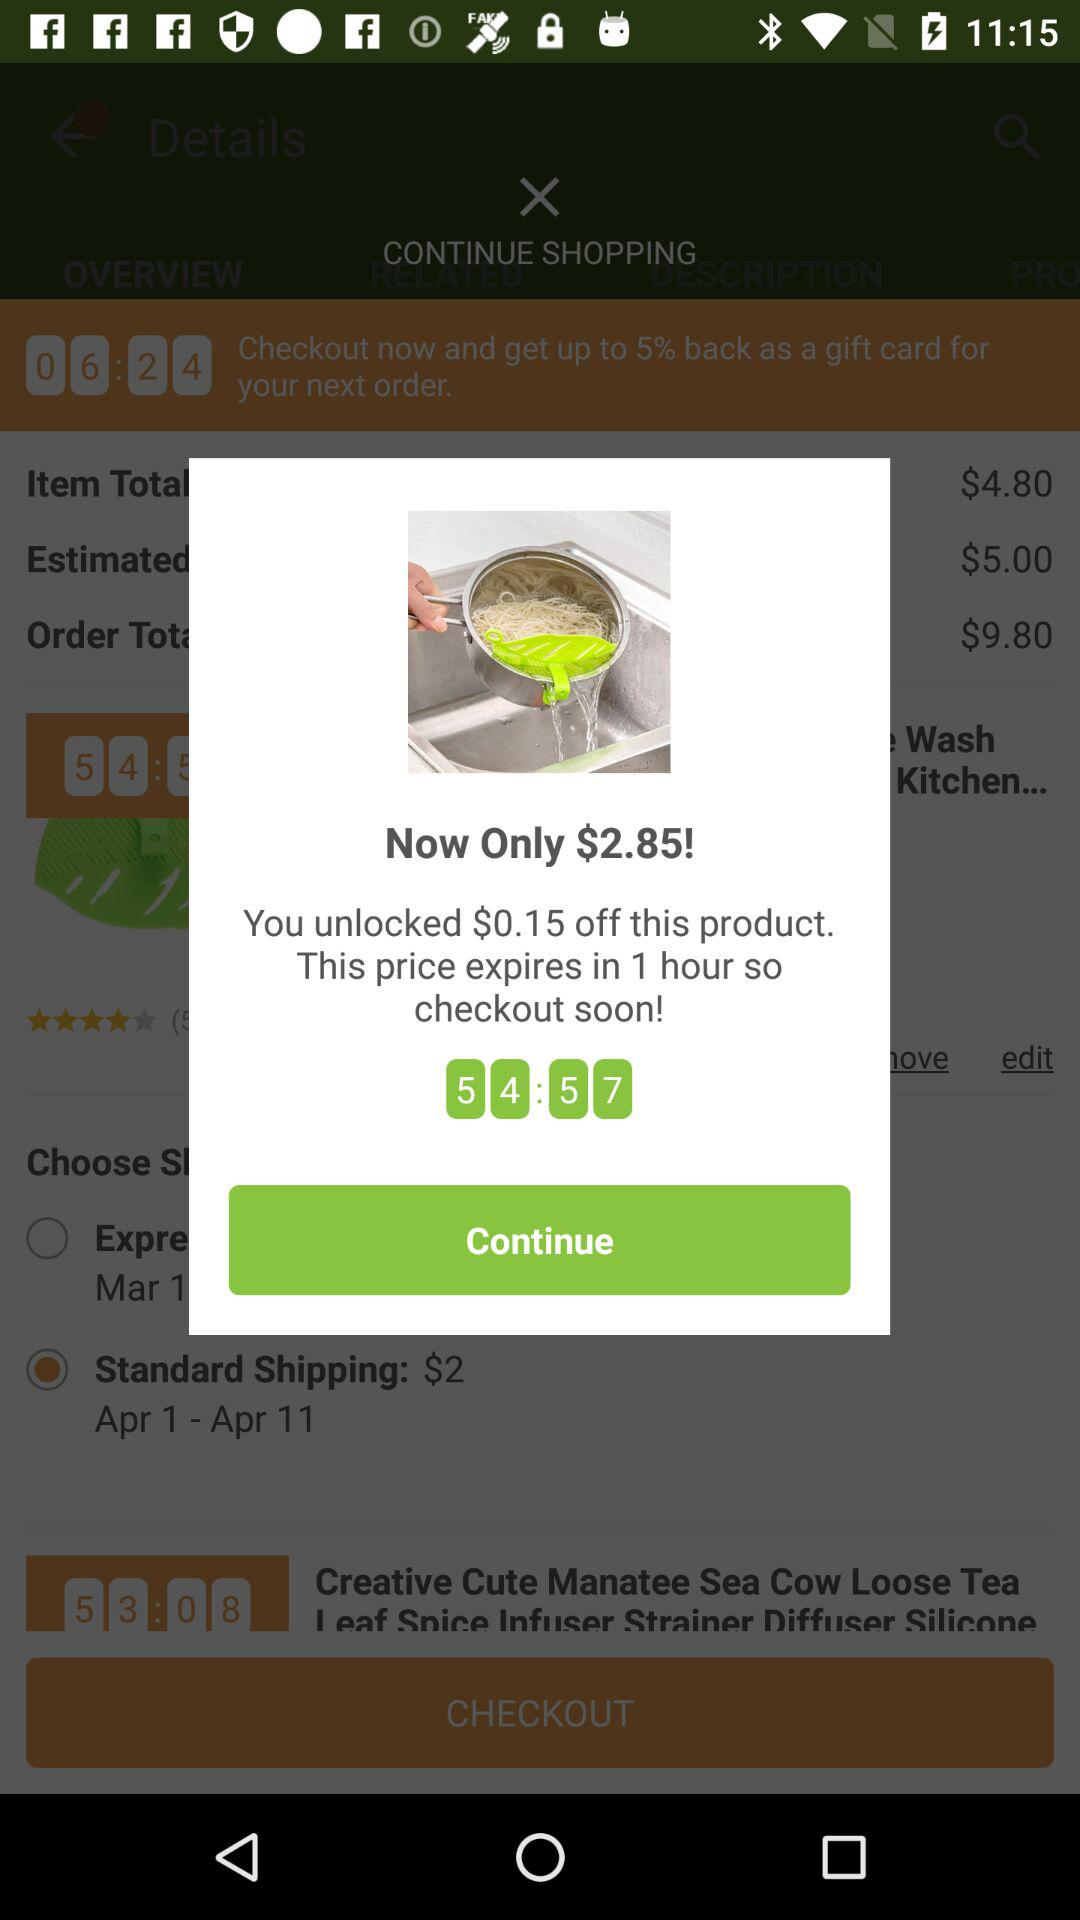What's the selected date for standard shipping? The selected date is from April 1 to April 11. 